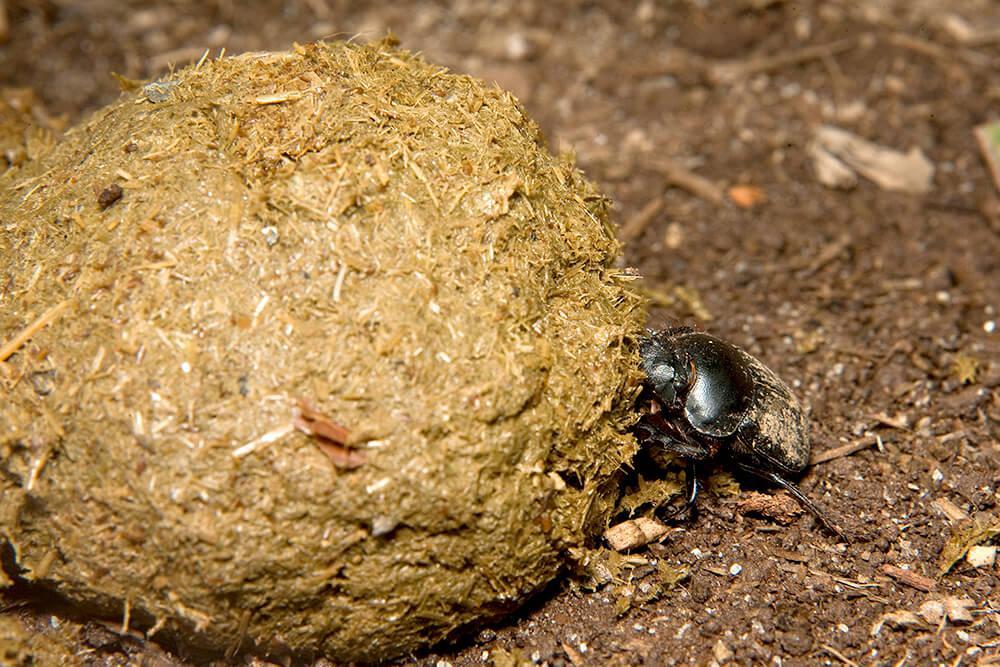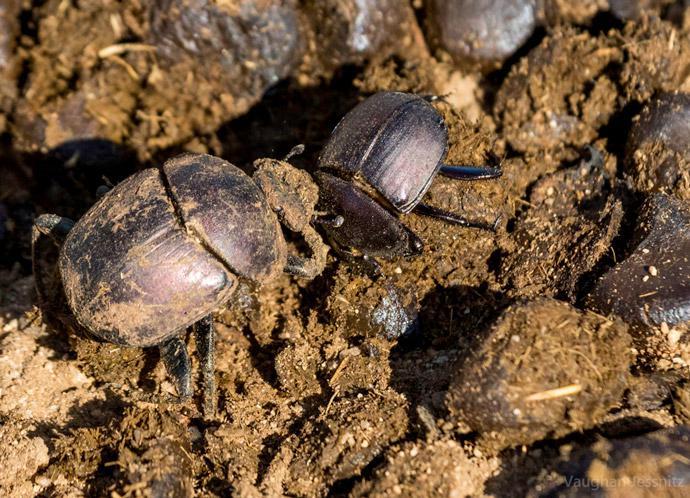The first image is the image on the left, the second image is the image on the right. Analyze the images presented: Is the assertion "In the image on the left, there is no more than one beetle present, industriously building the dung ball." valid? Answer yes or no. Yes. The first image is the image on the left, the second image is the image on the right. Analyze the images presented: Is the assertion "There is at most three beetles." valid? Answer yes or no. No. 